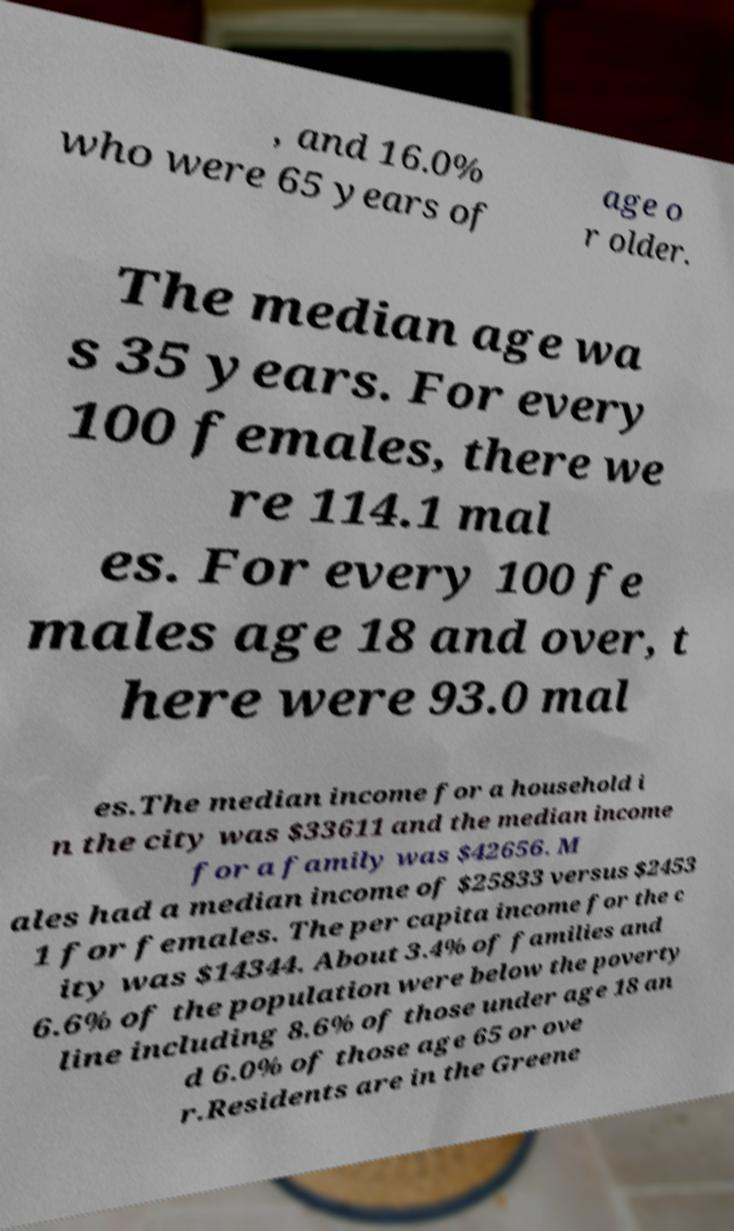Could you assist in decoding the text presented in this image and type it out clearly? , and 16.0% who were 65 years of age o r older. The median age wa s 35 years. For every 100 females, there we re 114.1 mal es. For every 100 fe males age 18 and over, t here were 93.0 mal es.The median income for a household i n the city was $33611 and the median income for a family was $42656. M ales had a median income of $25833 versus $2453 1 for females. The per capita income for the c ity was $14344. About 3.4% of families and 6.6% of the population were below the poverty line including 8.6% of those under age 18 an d 6.0% of those age 65 or ove r.Residents are in the Greene 